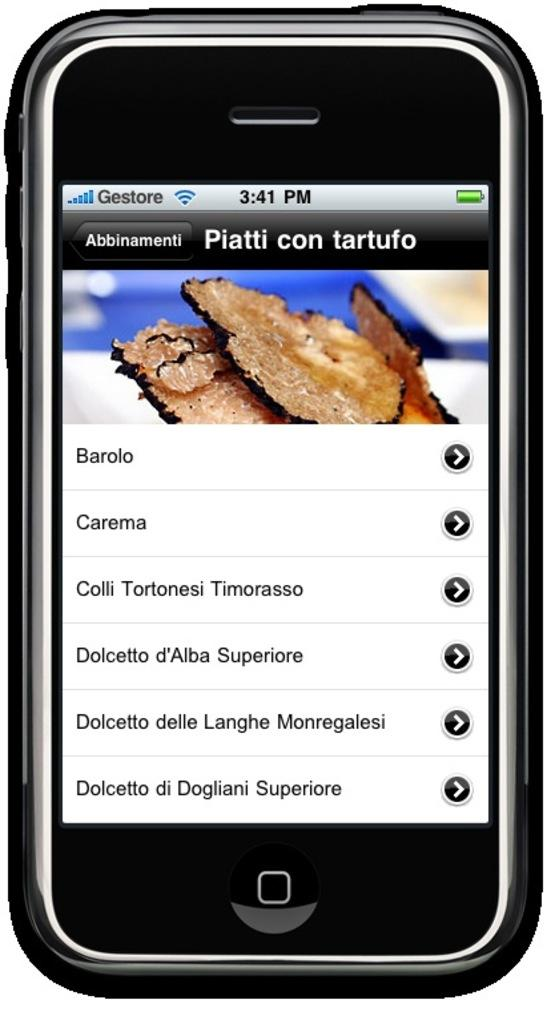<image>
Write a terse but informative summary of the picture. A black phone shows a screen titled Piatti con tartufo. 